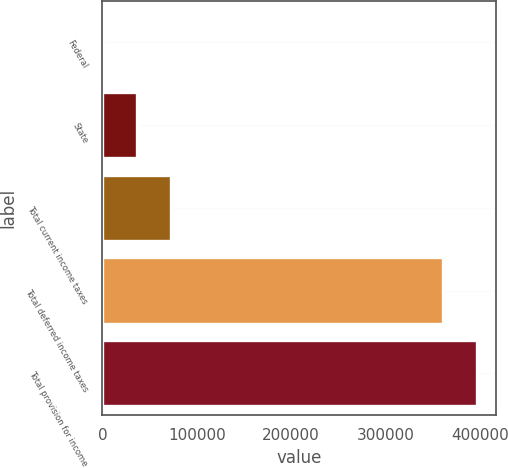Convert chart to OTSL. <chart><loc_0><loc_0><loc_500><loc_500><bar_chart><fcel>Federal<fcel>State<fcel>Total current income taxes<fcel>Total deferred income taxes<fcel>Total provision for income<nl><fcel>260<fcel>36524.3<fcel>72788.6<fcel>361010<fcel>397274<nl></chart> 